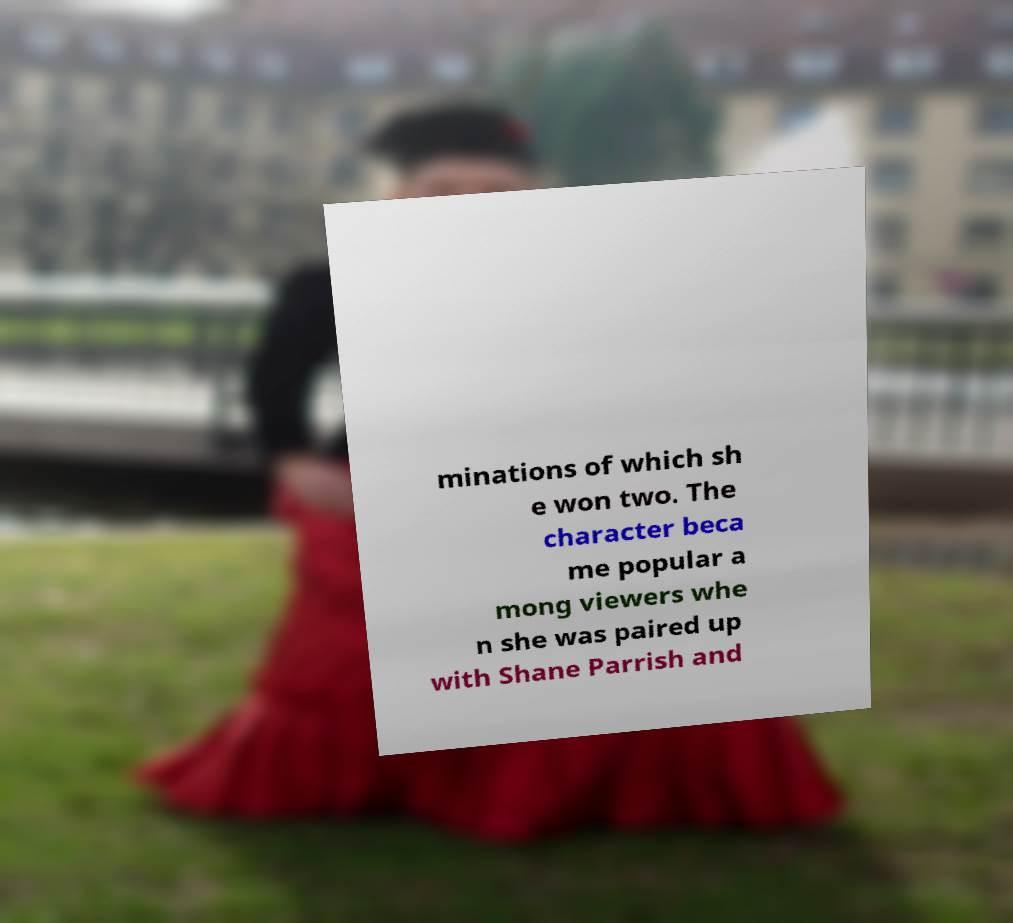Can you accurately transcribe the text from the provided image for me? minations of which sh e won two. The character beca me popular a mong viewers whe n she was paired up with Shane Parrish and 